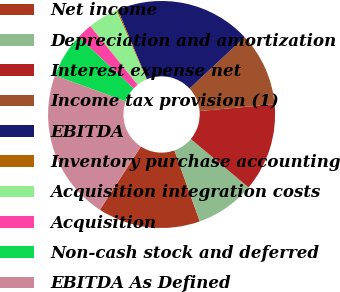Convert chart to OTSL. <chart><loc_0><loc_0><loc_500><loc_500><pie_chart><fcel>Net income<fcel>Depreciation and amortization<fcel>Interest expense net<fcel>Income tax provision (1)<fcel>EBITDA<fcel>Inventory purchase accounting<fcel>Acquisition integration costs<fcel>Acquisition<fcel>Non-cash stock and deferred<fcel>EBITDA As Defined<nl><fcel>14.61%<fcel>8.43%<fcel>12.55%<fcel>10.49%<fcel>19.37%<fcel>0.19%<fcel>4.31%<fcel>2.25%<fcel>6.37%<fcel>21.43%<nl></chart> 